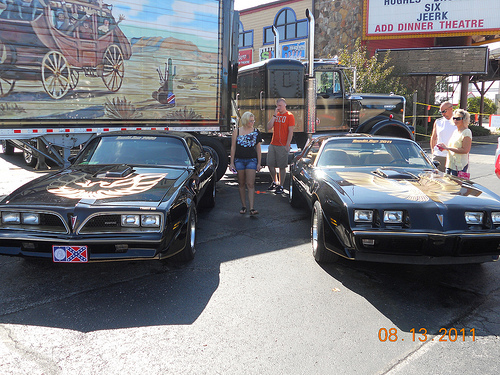<image>
Is there a man behind the car? Yes. From this viewpoint, the man is positioned behind the car, with the car partially or fully occluding the man. Is there a car next to the car? Yes. The car is positioned adjacent to the car, located nearby in the same general area. 